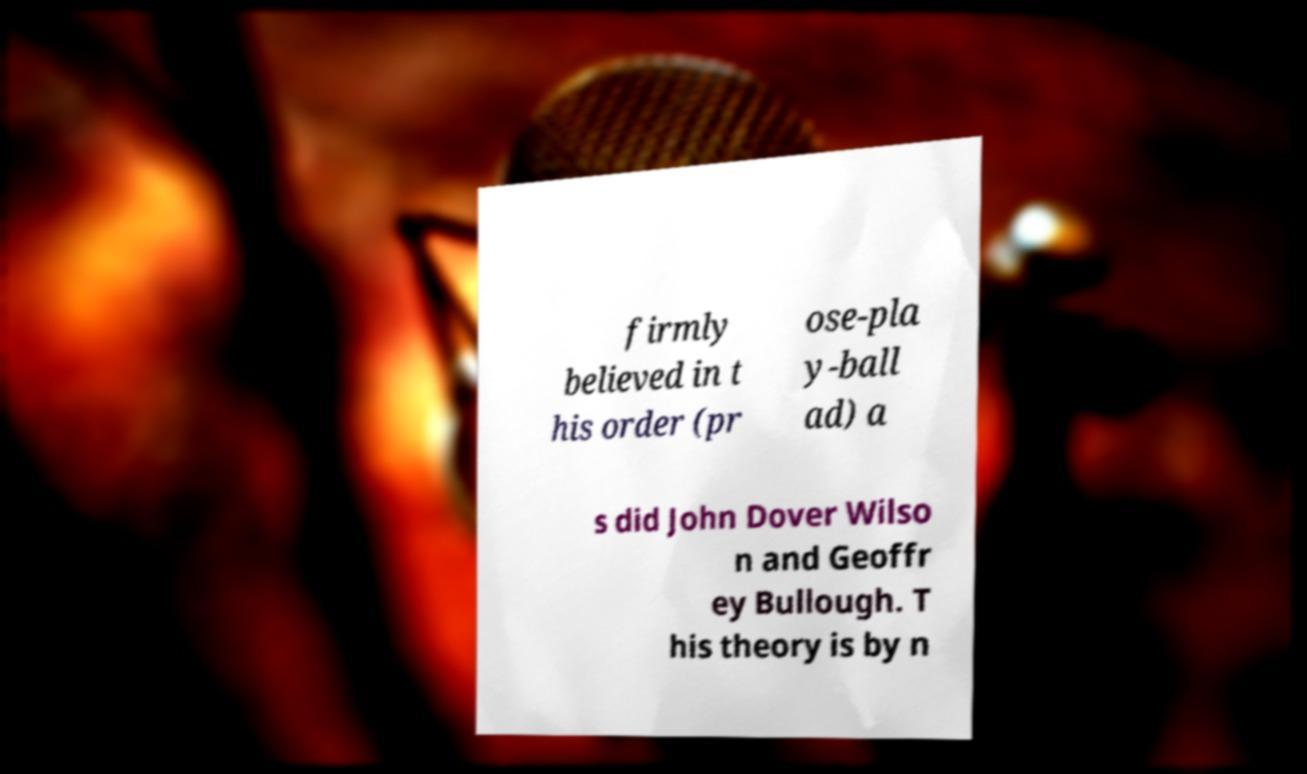Could you assist in decoding the text presented in this image and type it out clearly? firmly believed in t his order (pr ose-pla y-ball ad) a s did John Dover Wilso n and Geoffr ey Bullough. T his theory is by n 